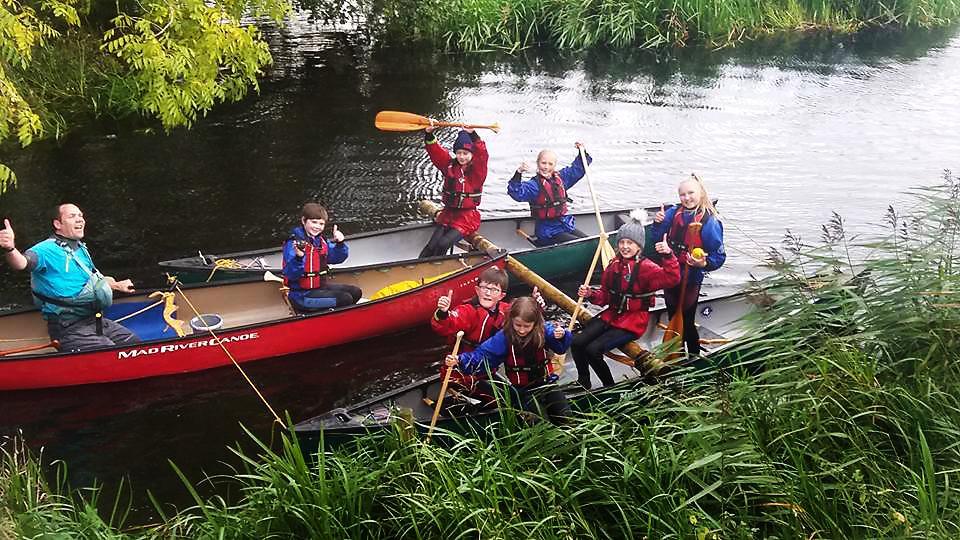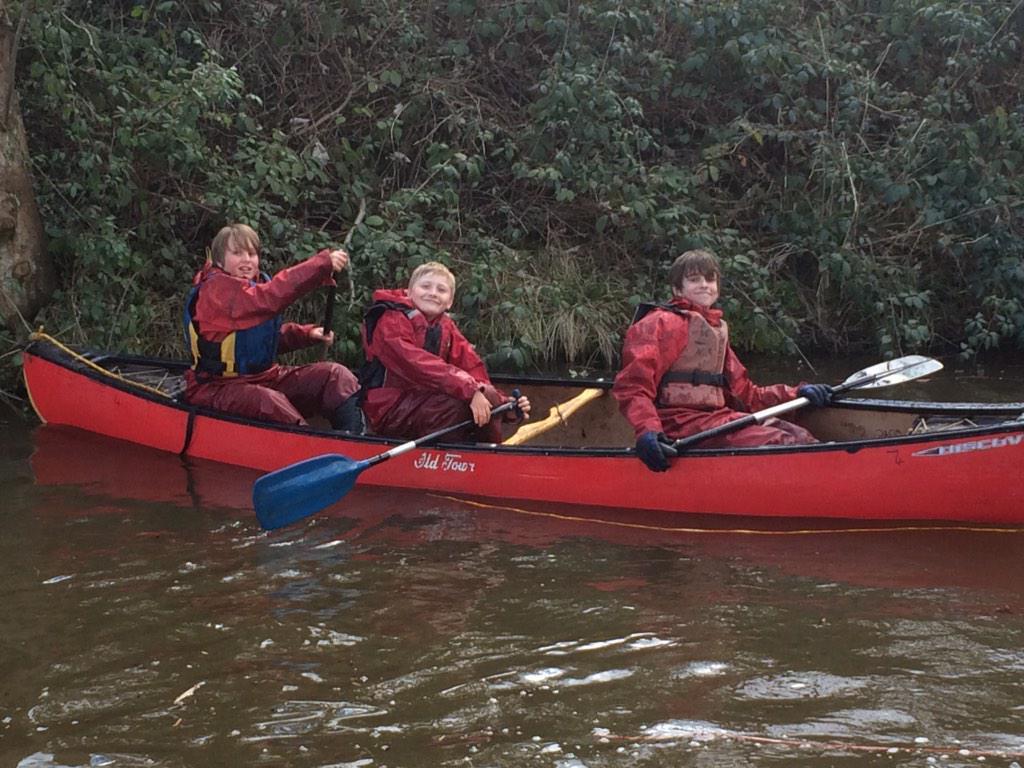The first image is the image on the left, the second image is the image on the right. Considering the images on both sides, is "The left and right image contains a total of four boats." valid? Answer yes or no. Yes. The first image is the image on the left, the second image is the image on the right. Assess this claim about the two images: "An image includes a red canoe with three riders and no other canoe with a seated person in it.". Correct or not? Answer yes or no. Yes. 